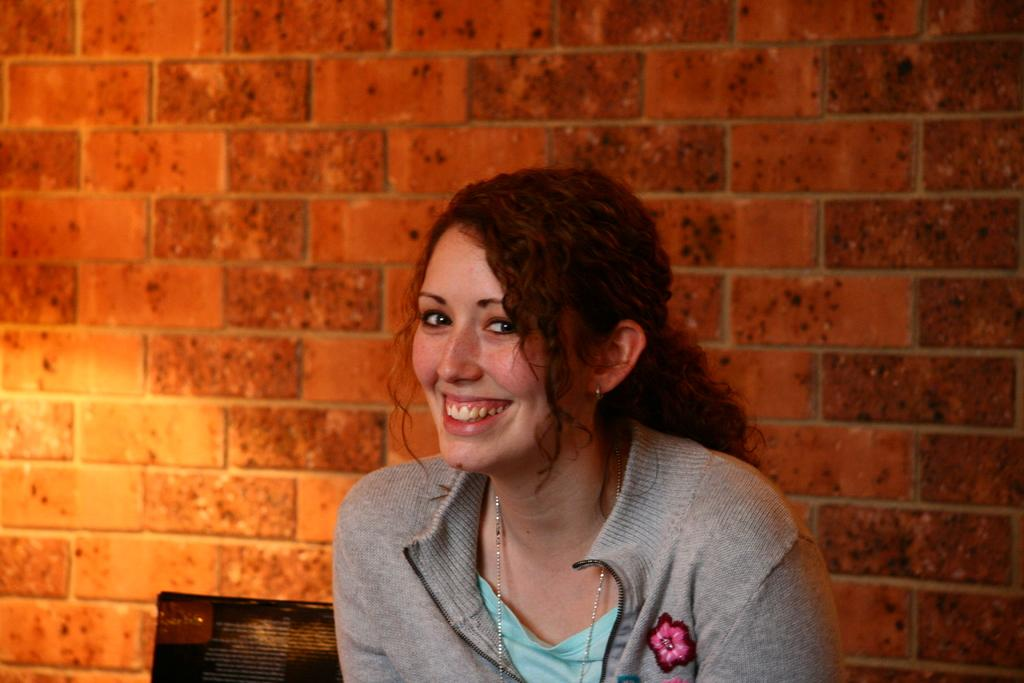What is the person in the image doing? The person is sitting in the image. What is the person wearing? The person is wearing a green and gray color dress. What can be seen in the background of the image? There is a wall in the background of the image. What color is the wall? The wall is in brown color. Can you tell me how many berries are on the person's knee in the image? There are no berries present on the person's knee in the image. Is there a stranger interacting with the person in the image? There is no stranger interacting with the person in the image; only the person sitting is visible. 